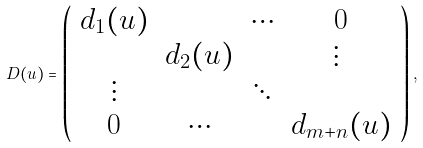<formula> <loc_0><loc_0><loc_500><loc_500>D ( u ) = \left ( \begin{array} { c c c c } d _ { 1 } ( u ) & & \cdots & 0 \\ & d _ { 2 } ( u ) & & \vdots \ \\ \vdots & & \ddots & \\ 0 & \cdots & & d _ { m + n } ( u ) \end{array} \right ) ,</formula> 